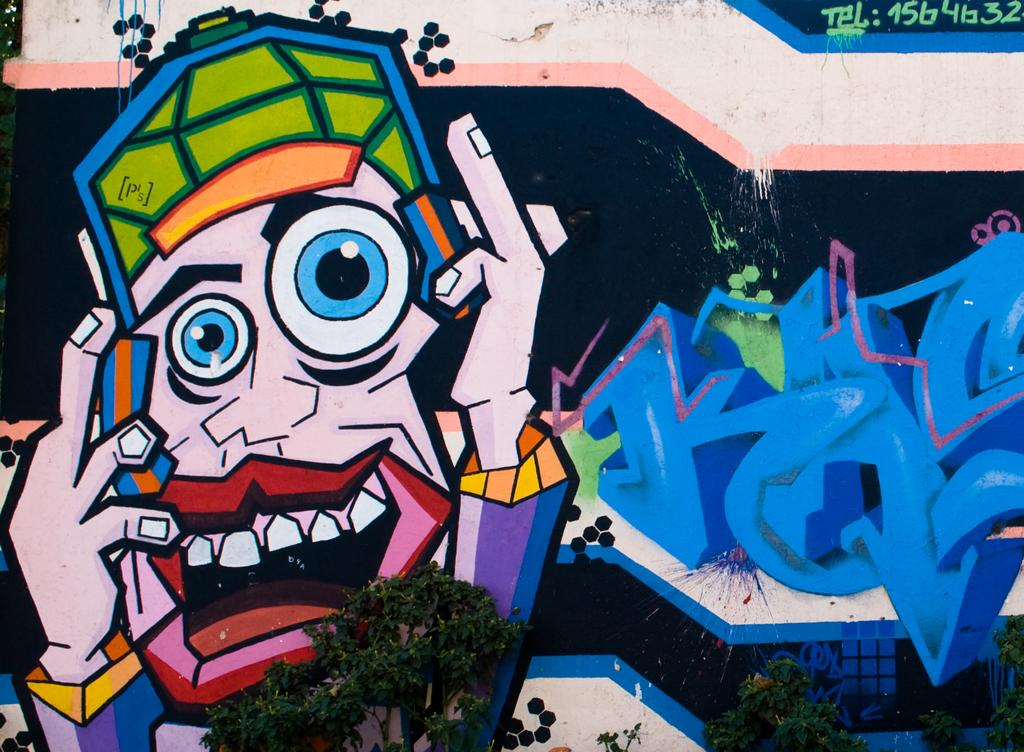What is depicted on the wall in the image? There is a painting on the wall in the image. What else can be seen in front of the wall in the image? There are plants in front of the wall in the image. What news is being reported by the boys in the image? There are no boys present in the image, and therefore no news is being reported. What is the tendency of the plants to grow in the image? The provided facts do not mention the growth or tendency of the plants, so we cannot determine this information from the image. 